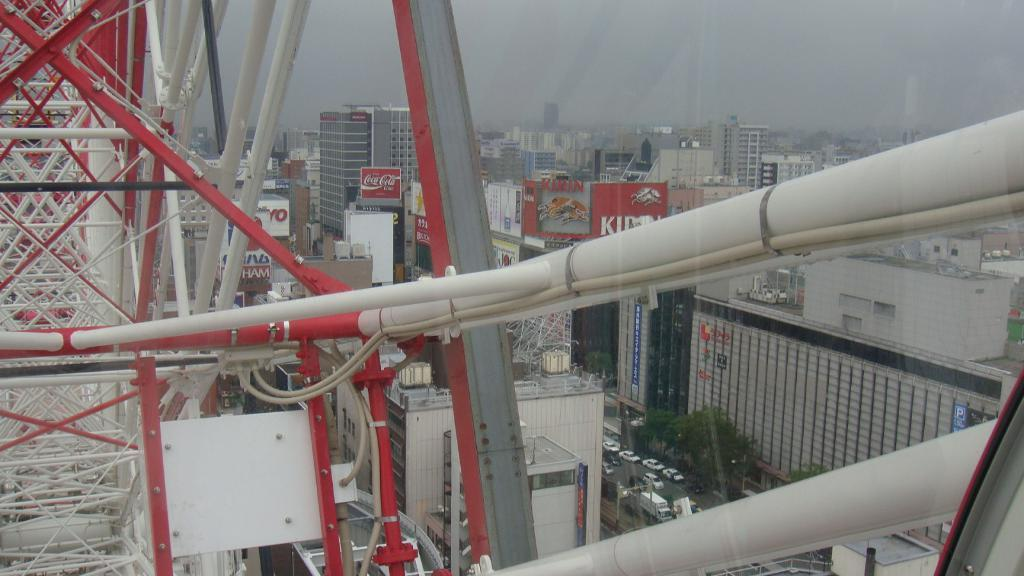What colors are the rods in the image? The rods in the image are red and white. What can be seen in the background of the image? There are buildings, vehicles, trees, and the sky visible in the background of the image. What language is being spoken by the cushion in the image? There is no cushion present in the image, and therefore no language can be associated with it. 